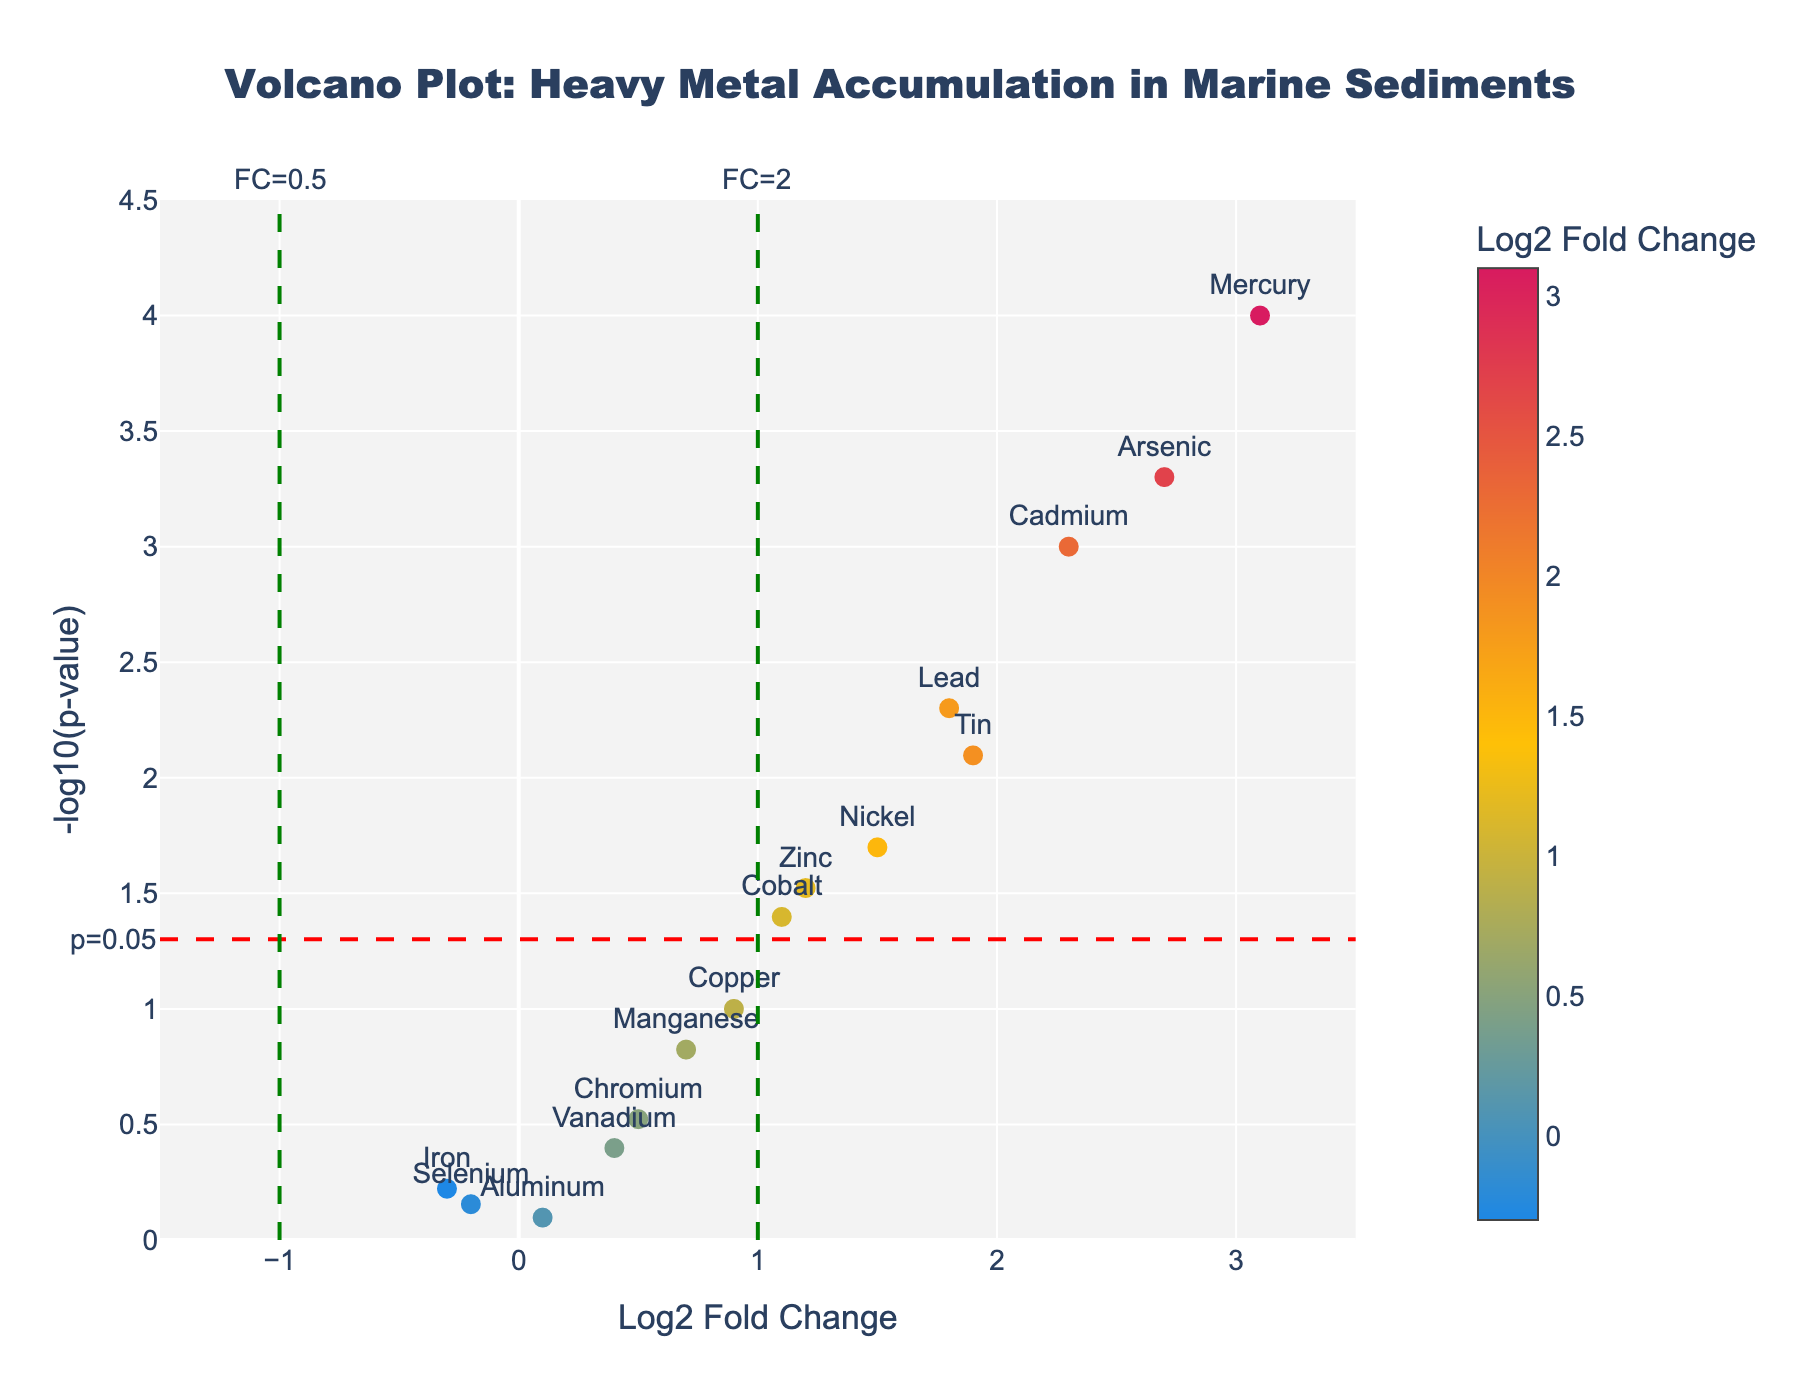What is the title of the plot? The title is typically located at the top of the figure. In this case, it is "Volcano Plot: Heavy Metal Accumulation in Marine Sediments".
Answer: Volcano Plot: Heavy Metal Accumulation in Marine Sediments Which element has the highest -log10(p-value)? By looking at the y-axis (representing -log10(p-value)), the element with the highest value is Mercury.
Answer: Mercury What is the log2 fold change for Lead? Find the data point labeled "Lead" and note its position on the x-axis. The x-coordinate for Lead is 1.8.
Answer: 1.8 How many elements have a p-value less than 0.05? Elements with -log10(p-value) above the threshold line at 1.3 (since -log10(0.05) ≈ 1.3) are considered significant. These elements are Cadmium, Lead, Mercury, Zinc, Arsenic, Nickel, Cobalt, and Tin. Counting these gives us 8.
Answer: 8 What is the significance threshold indicated with a red line? The red line indicates the significance threshold, which is marked at -log10(p)=1.3, corresponding to a p-value of 0.05.
Answer: 0.05 Which two elements show the highest positive log2 fold changes? By examining the x-axis for the highest points on the right side, Mercury and Arsenic have the highest positive log2 fold changes of 3.1 and 2.7, respectively.
Answer: Mercury and Arsenic Which element has the smallest log2 fold change? Look for the data point farthest to the left on the x-axis. The element with the smallest log2 fold change is Iron, with a value of -0.3.
Answer: Iron Do any elements show a negative log2 fold change but are not significant? For an element to be non-significant, its -log10(p) must be below the red threshold line at 1.3. Selenium and Iron have negative log2 fold changes and are below the threshold.
Answer: Selenium and Iron Which element is located closest to the origin (0,0)? Look for the data point nearest to the intersection of the x- and y-axes. Aluminum, with a log2 fold change of 0.1 and -log10(p) around 0.1, is closest to the origin.
Answer: Aluminum How many elements have log2 fold changes between 1 and 2? Identify the elements that fall within the range on the x-axis between 1 and 2. These elements are Lead, Zinc, Nickel, and Cobalt. Thus, there are 4 elements in this range.
Answer: 4 